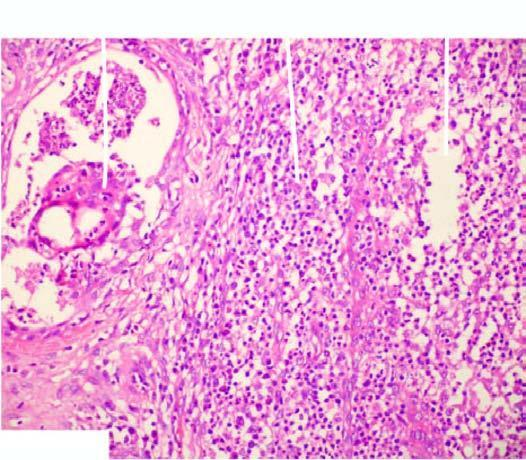s there presence of a lipogranuloma having central pool of fat and surrounded by mixed inflammatory cells and foreign body type multinucleated giant cells?
Answer the question using a single word or phrase. Yes 